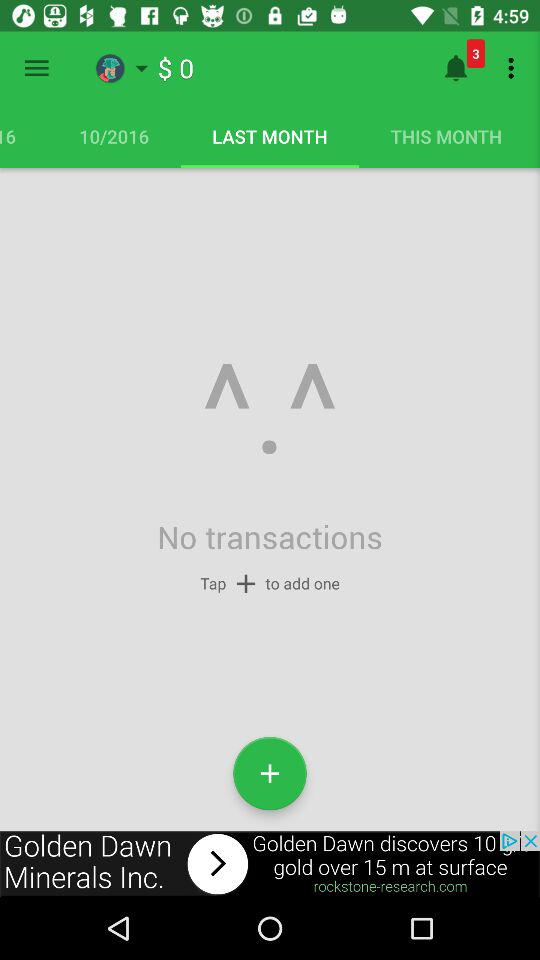Which tab is selected? The selected tab is "LAST MONTH". 